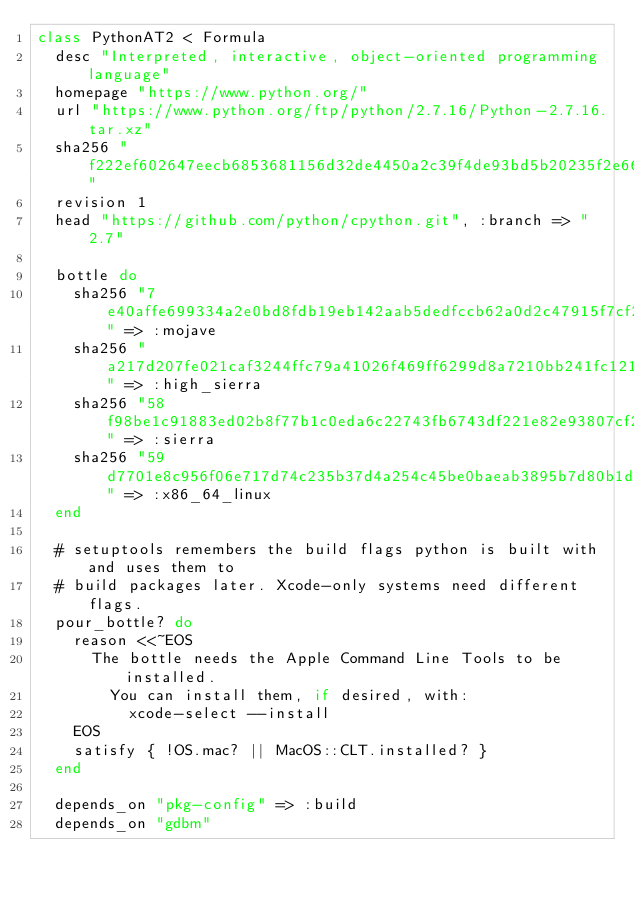Convert code to text. <code><loc_0><loc_0><loc_500><loc_500><_Ruby_>class PythonAT2 < Formula
  desc "Interpreted, interactive, object-oriented programming language"
  homepage "https://www.python.org/"
  url "https://www.python.org/ftp/python/2.7.16/Python-2.7.16.tar.xz"
  sha256 "f222ef602647eecb6853681156d32de4450a2c39f4de93bd5b20235f2e660ed7"
  revision 1
  head "https://github.com/python/cpython.git", :branch => "2.7"

  bottle do
    sha256 "7e40affe699334a2e0bd8fdb19eb142aab5dedfccb62a0d2c47915f7cf25bafd" => :mojave
    sha256 "a217d207fe021caf3244ffc79a41026f469ff6299d8a7210bb241fc121421584" => :high_sierra
    sha256 "58f98be1c91883ed02b8f77b1c0eda6c22743fb6743df221e82e93807cf21ac0" => :sierra
    sha256 "59d7701e8c956f06e717d74c235b37d4a254c45be0baeab3895b7d80b1dfc05d" => :x86_64_linux
  end

  # setuptools remembers the build flags python is built with and uses them to
  # build packages later. Xcode-only systems need different flags.
  pour_bottle? do
    reason <<~EOS
      The bottle needs the Apple Command Line Tools to be installed.
        You can install them, if desired, with:
          xcode-select --install
    EOS
    satisfy { !OS.mac? || MacOS::CLT.installed? }
  end

  depends_on "pkg-config" => :build
  depends_on "gdbm"</code> 